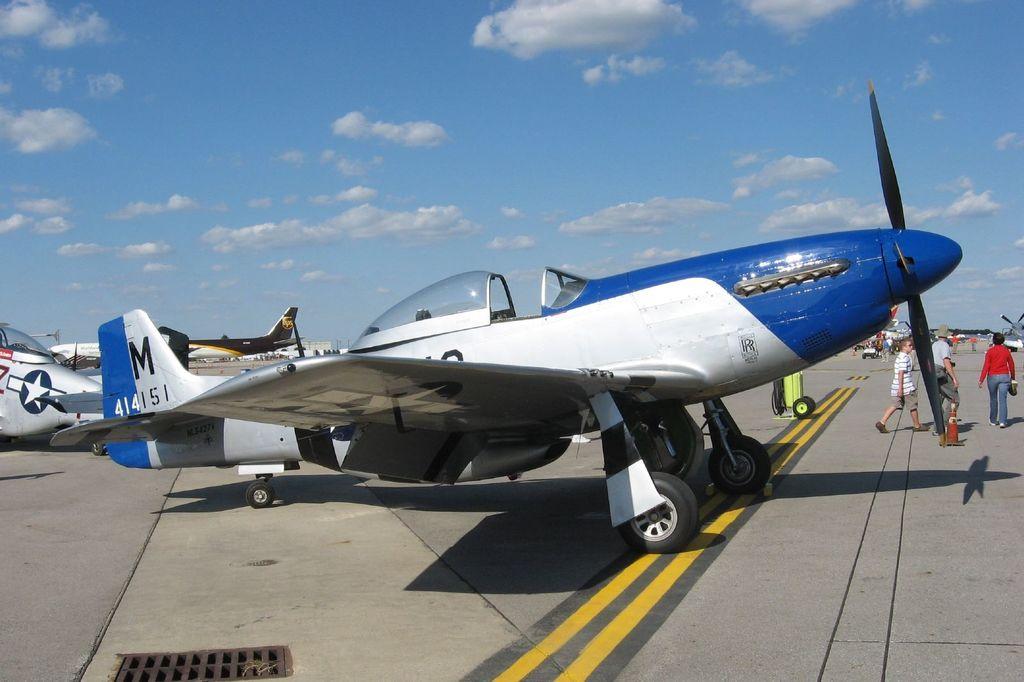What is the plane number?
Provide a short and direct response. 414151. What package delivery company owns the brown plane?
Make the answer very short. Ups. 